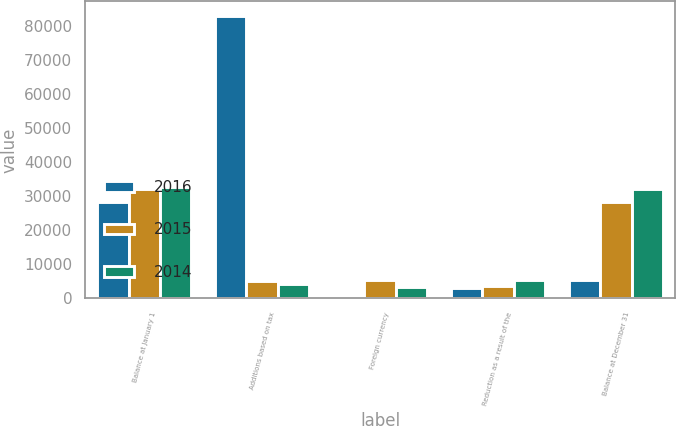Convert chart. <chart><loc_0><loc_0><loc_500><loc_500><stacked_bar_chart><ecel><fcel>Balance at January 1<fcel>Additions based on tax<fcel>Foreign currency<fcel>Reduction as a result of the<fcel>Balance at December 31<nl><fcel>2016<fcel>28114<fcel>82912<fcel>307<fcel>3168<fcel>5360<nl><fcel>2015<fcel>31947<fcel>5042<fcel>5371<fcel>3504<fcel>28114<nl><fcel>2014<fcel>32545<fcel>4187<fcel>3216<fcel>5349<fcel>31947<nl></chart> 